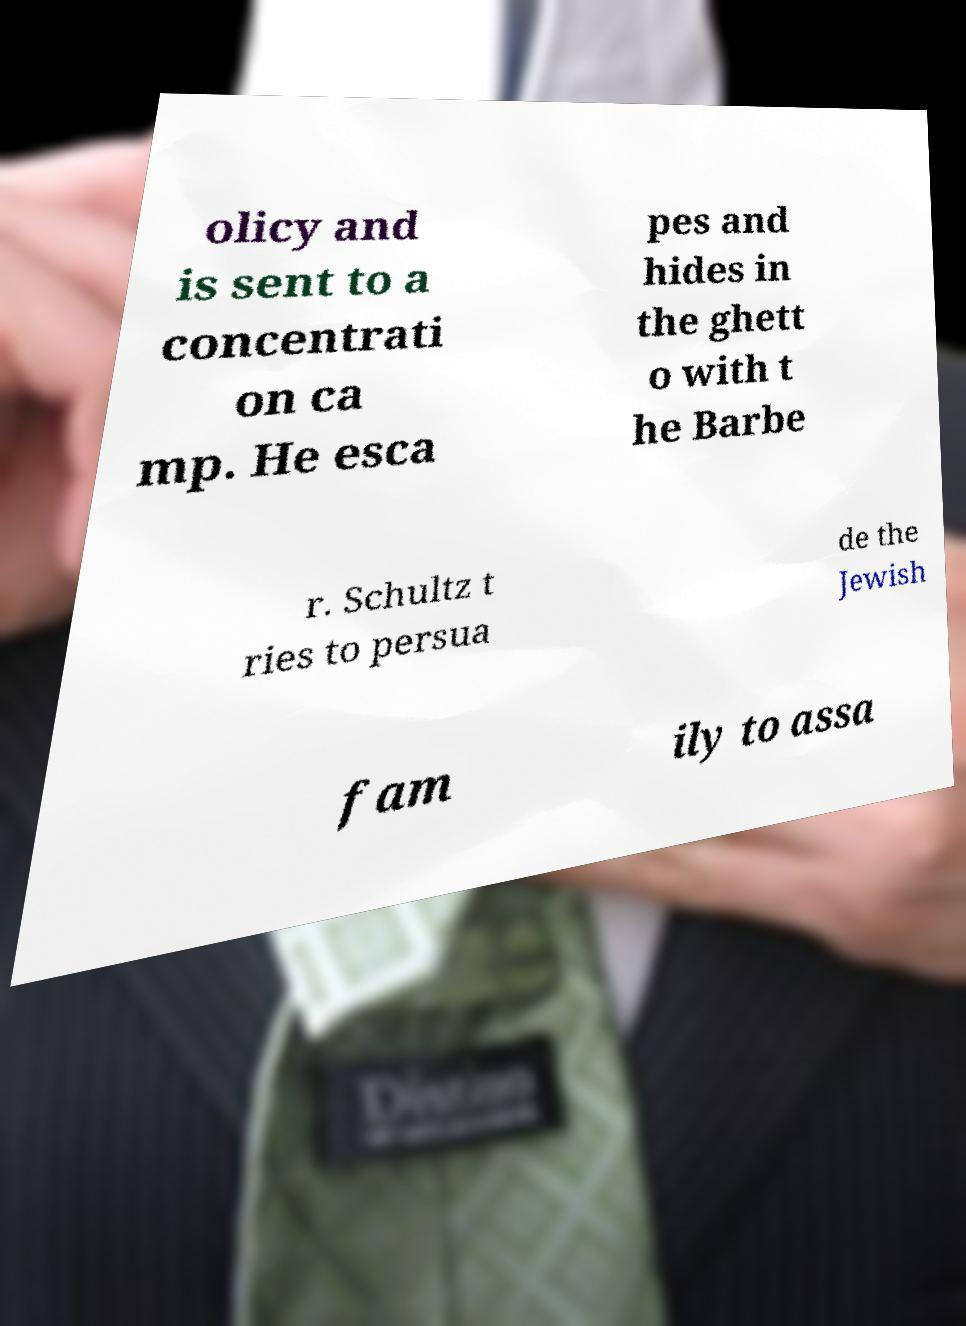Please identify and transcribe the text found in this image. olicy and is sent to a concentrati on ca mp. He esca pes and hides in the ghett o with t he Barbe r. Schultz t ries to persua de the Jewish fam ily to assa 